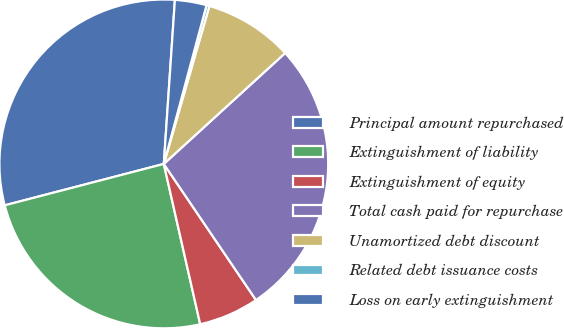Convert chart. <chart><loc_0><loc_0><loc_500><loc_500><pie_chart><fcel>Principal amount repurchased<fcel>Extinguishment of liability<fcel>Extinguishment of equity<fcel>Total cash paid for repurchase<fcel>Unamortized debt discount<fcel>Related debt issuance costs<fcel>Loss on early extinguishment<nl><fcel>30.13%<fcel>24.5%<fcel>5.92%<fcel>27.31%<fcel>8.74%<fcel>0.29%<fcel>3.11%<nl></chart> 